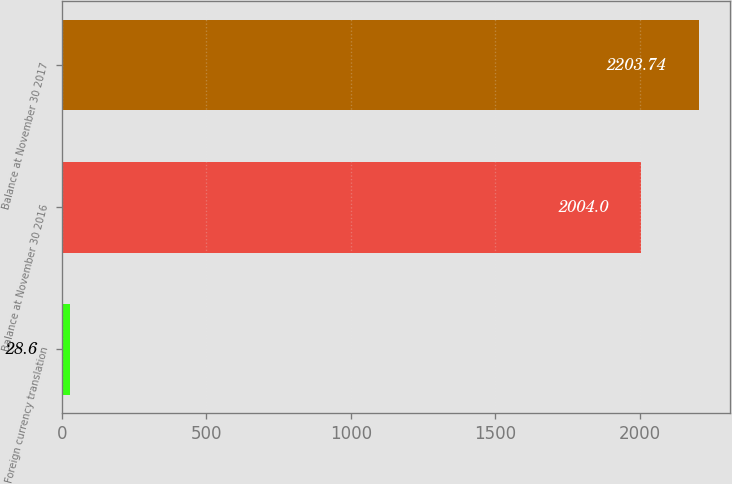Convert chart. <chart><loc_0><loc_0><loc_500><loc_500><bar_chart><fcel>Foreign currency translation<fcel>Balance at November 30 2016<fcel>Balance at November 30 2017<nl><fcel>28.6<fcel>2004<fcel>2203.74<nl></chart> 